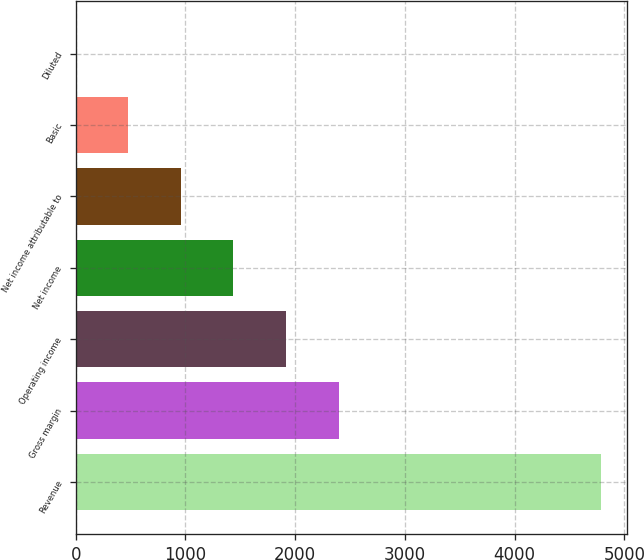<chart> <loc_0><loc_0><loc_500><loc_500><bar_chart><fcel>Revenue<fcel>Gross margin<fcel>Operating income<fcel>Net income<fcel>Net income attributable to<fcel>Basic<fcel>Diluted<nl><fcel>4788<fcel>2394.39<fcel>1915.66<fcel>1436.93<fcel>958.2<fcel>479.47<fcel>0.74<nl></chart> 